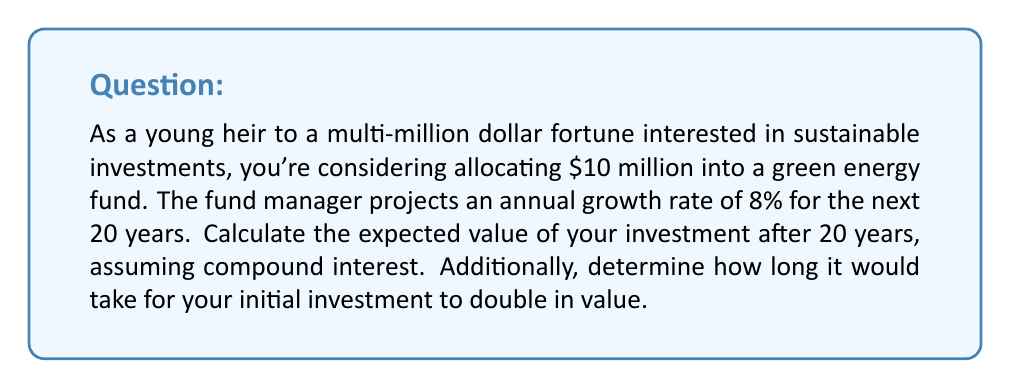Give your solution to this math problem. To solve this problem, we'll use the exponential growth formula and the rule of 72 for doubling time.

1. Calculating the expected value after 20 years:
The exponential growth formula is:

$$ A = P(1 + r)^t $$

Where:
$A$ = Final amount
$P$ = Principal (initial investment)
$r$ = Annual growth rate (as a decimal)
$t$ = Time in years

Given:
$P = \$10,000,000$
$r = 0.08$ (8% expressed as a decimal)
$t = 20$ years

Plugging these values into the formula:

$$ A = 10,000,000(1 + 0.08)^{20} $$
$$ A = 10,000,000(1.08)^{20} $$
$$ A = 10,000,000(4.6609) $$
$$ A = \$46,609,000 $$

2. Determining the time it takes for the investment to double:
We can use the Rule of 72, which is an approximation for calculating doubling time:

$$ \text{Doubling Time} \approx \frac{72}{\text{Growth Rate (%)}} $$

In this case:

$$ \text{Doubling Time} \approx \frac{72}{8} = 9 \text{ years} $$

For a more precise calculation, we can use the exact formula:

$$ \text{Doubling Time} = \frac{\ln(2)}{\ln(1 + r)} $$

$$ \text{Doubling Time} = \frac{\ln(2)}{\ln(1.08)} \approx 9.006 \text{ years} $$

This confirms that our Rule of 72 approximation is quite accurate for this growth rate.
Answer: The expected value of the $10 million investment after 20 years is $46,609,000. The initial investment would double in approximately 9 years. 